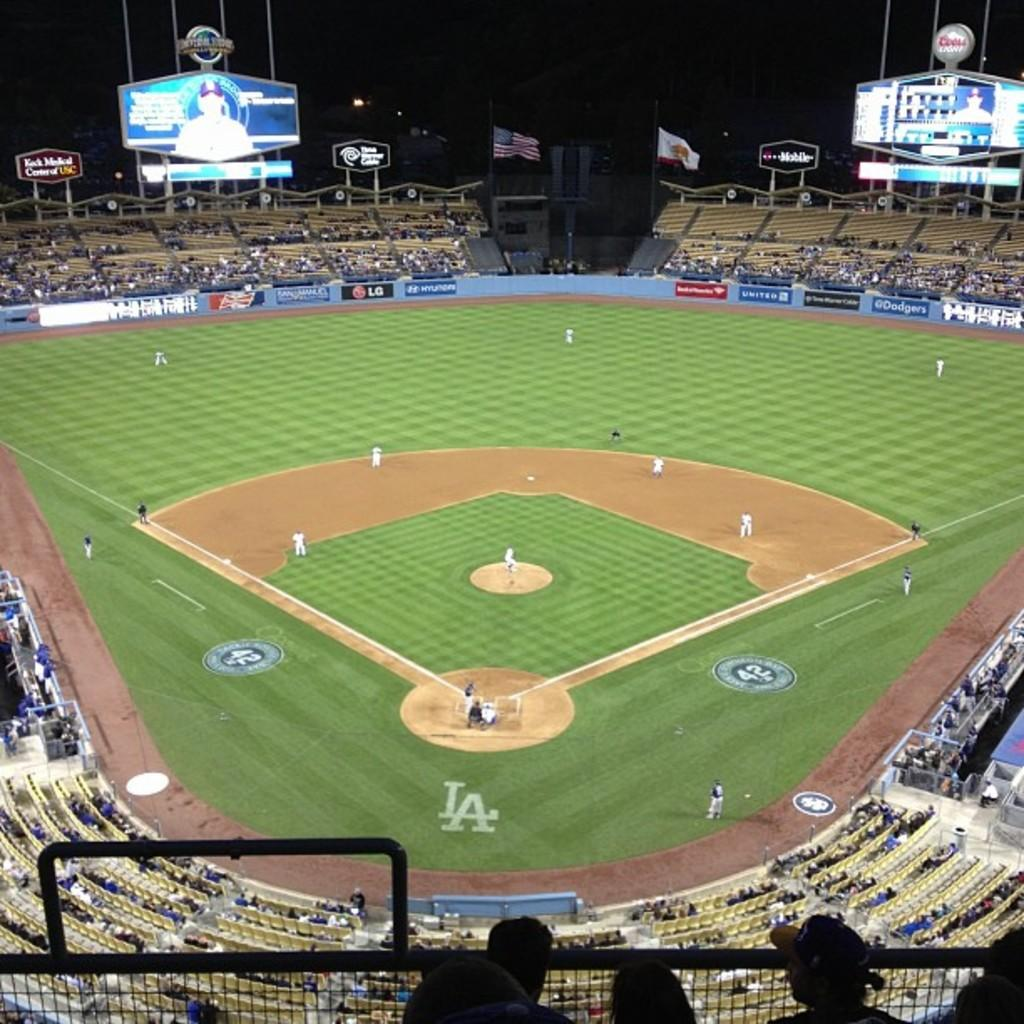<image>
Render a clear and concise summary of the photo. a baseball diamond with the word LA behind the homebase 